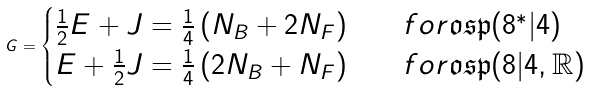<formula> <loc_0><loc_0><loc_500><loc_500>G = \begin{cases} \frac { 1 } { 2 } E + J = \frac { 1 } { 4 } \left ( N _ { B } + 2 N _ { F } \right ) & \quad f o r \mathfrak { o s p } ( 8 ^ { * } | 4 ) \\ E + \frac { 1 } { 2 } J = \frac { 1 } { 4 } \left ( 2 N _ { B } + N _ { F } \right ) & \quad f o r \mathfrak { o s p } ( 8 | 4 , \mathbb { R } ) \end{cases}</formula> 